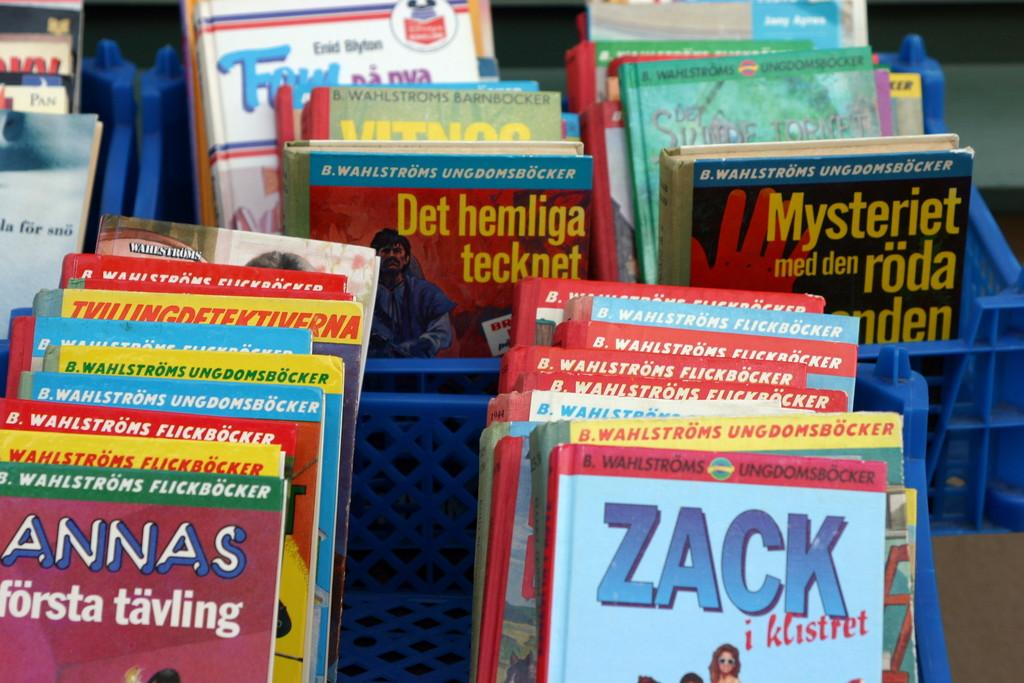<image>
Write a terse but informative summary of the picture. Some kids books are on the rack and one of the book is about a person named Zack. 